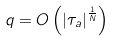<formula> <loc_0><loc_0><loc_500><loc_500>q = O \left ( \left | \tau _ { a } \right | ^ { \frac { 1 } { N } } \right )</formula> 